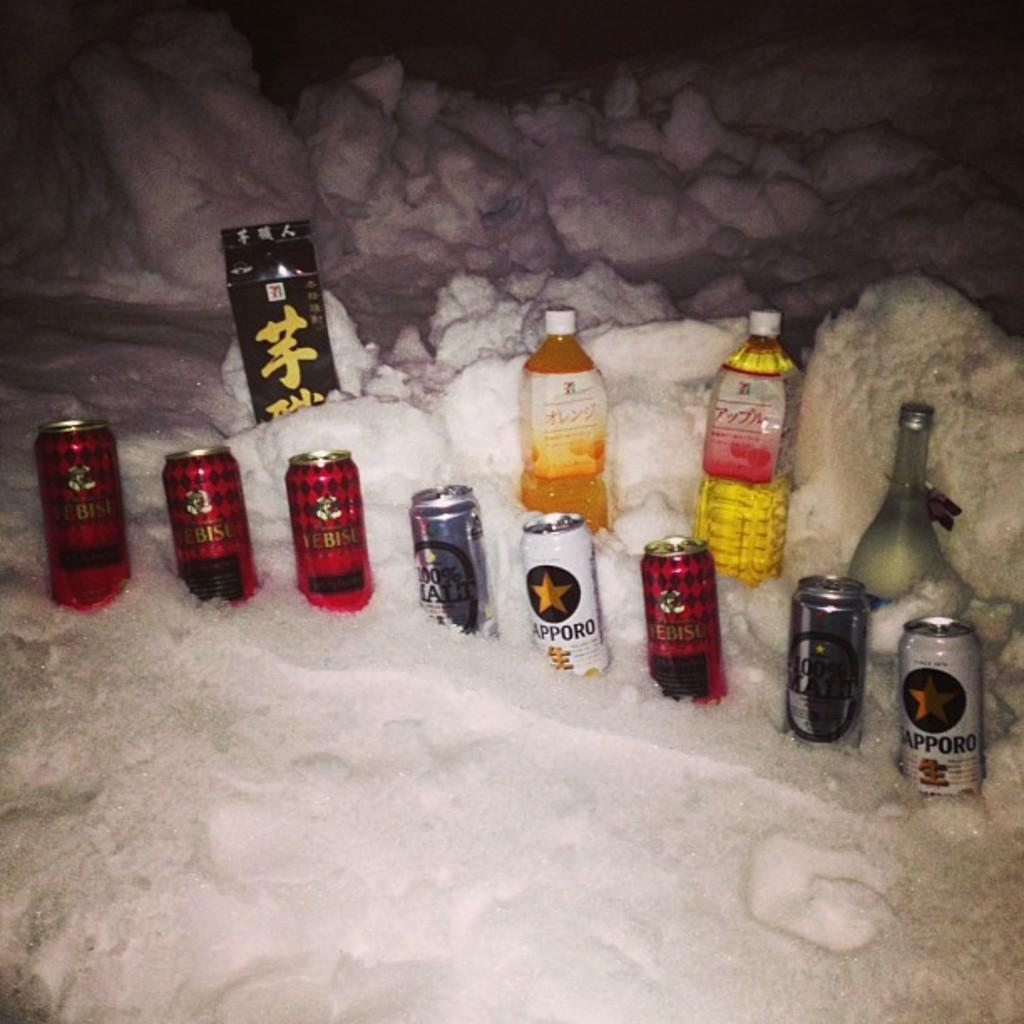Provide a one-sentence caption for the provided image. A couple of Sapporo beers sit in ice along with other brands. 